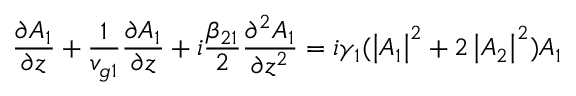<formula> <loc_0><loc_0><loc_500><loc_500>\frac { \partial A _ { 1 } } { \partial z } + \frac { 1 } { v _ { g 1 } } \frac { \partial A _ { 1 } } { \partial z } + i \frac { \beta _ { 2 1 } } { 2 } \frac { \partial ^ { 2 } A _ { 1 } } { \partial z ^ { 2 } } = i \gamma _ { 1 } ( \left | A _ { 1 } \right | ^ { 2 } + 2 \left | A _ { 2 } \right | ^ { 2 } ) A _ { 1 }</formula> 